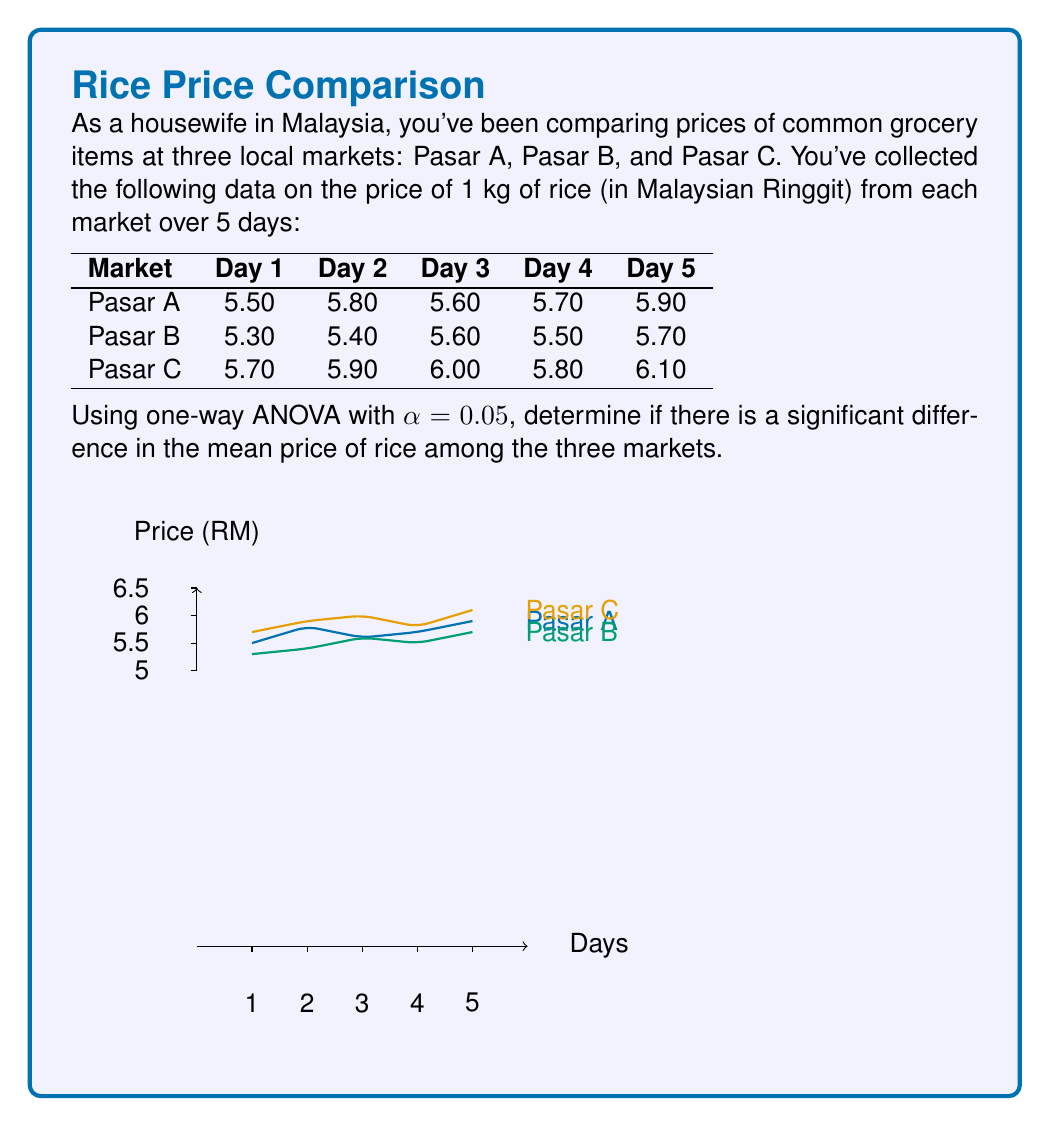Can you answer this question? Let's solve this problem step by step:

1) First, we need to calculate the sum of squares:

   SST (Total Sum of Squares)
   SSB (Between-group Sum of Squares)
   SSW (Within-group Sum of Squares)

2) Calculate the means for each group and the overall mean:

   $\bar{X}_A = 5.70$
   $\bar{X}_B = 5.50$
   $\bar{X}_C = 5.90$
   $\bar{X}_{\text{total}} = 5.70$

3) Calculate SST:
   $$SST = \sum_{i=1}^{n} (X_i - \bar{X}_{\text{total}})^2 = 1.06$$

4) Calculate SSB:
   $$SSB = n_A(\bar{X}_A - \bar{X}_{\text{total}})^2 + n_B(\bar{X}_B - \bar{X}_{\text{total}})^2 + n_C(\bar{X}_C - \bar{X}_{\text{total}})^2 = 0.52$$

5) Calculate SSW:
   $$SSW = SST - SSB = 1.06 - 0.52 = 0.54$$

6) Calculate degrees of freedom:
   dfB (between groups) = k - 1 = 3 - 1 = 2
   dfW (within groups) = N - k = 15 - 3 = 12
   where k is the number of groups and N is the total number of observations.

7) Calculate Mean Squares:
   $$MSB = \frac{SSB}{dfB} = \frac{0.52}{2} = 0.26$$
   $$MSW = \frac{SSW}{dfW} = \frac{0.54}{12} = 0.045$$

8) Calculate F-statistic:
   $$F = \frac{MSB}{MSW} = \frac{0.26}{0.045} = 5.78$$

9) Find the critical F-value:
   For α = 0.05, dfB = 2, and dfW = 12, the critical F-value is approximately 3.89.

10) Compare F-statistic to critical F-value:
    Since 5.78 > 3.89, we reject the null hypothesis.
Answer: There is a significant difference in the mean price of rice among the three markets (F(2,12) = 5.78, p < 0.05). 